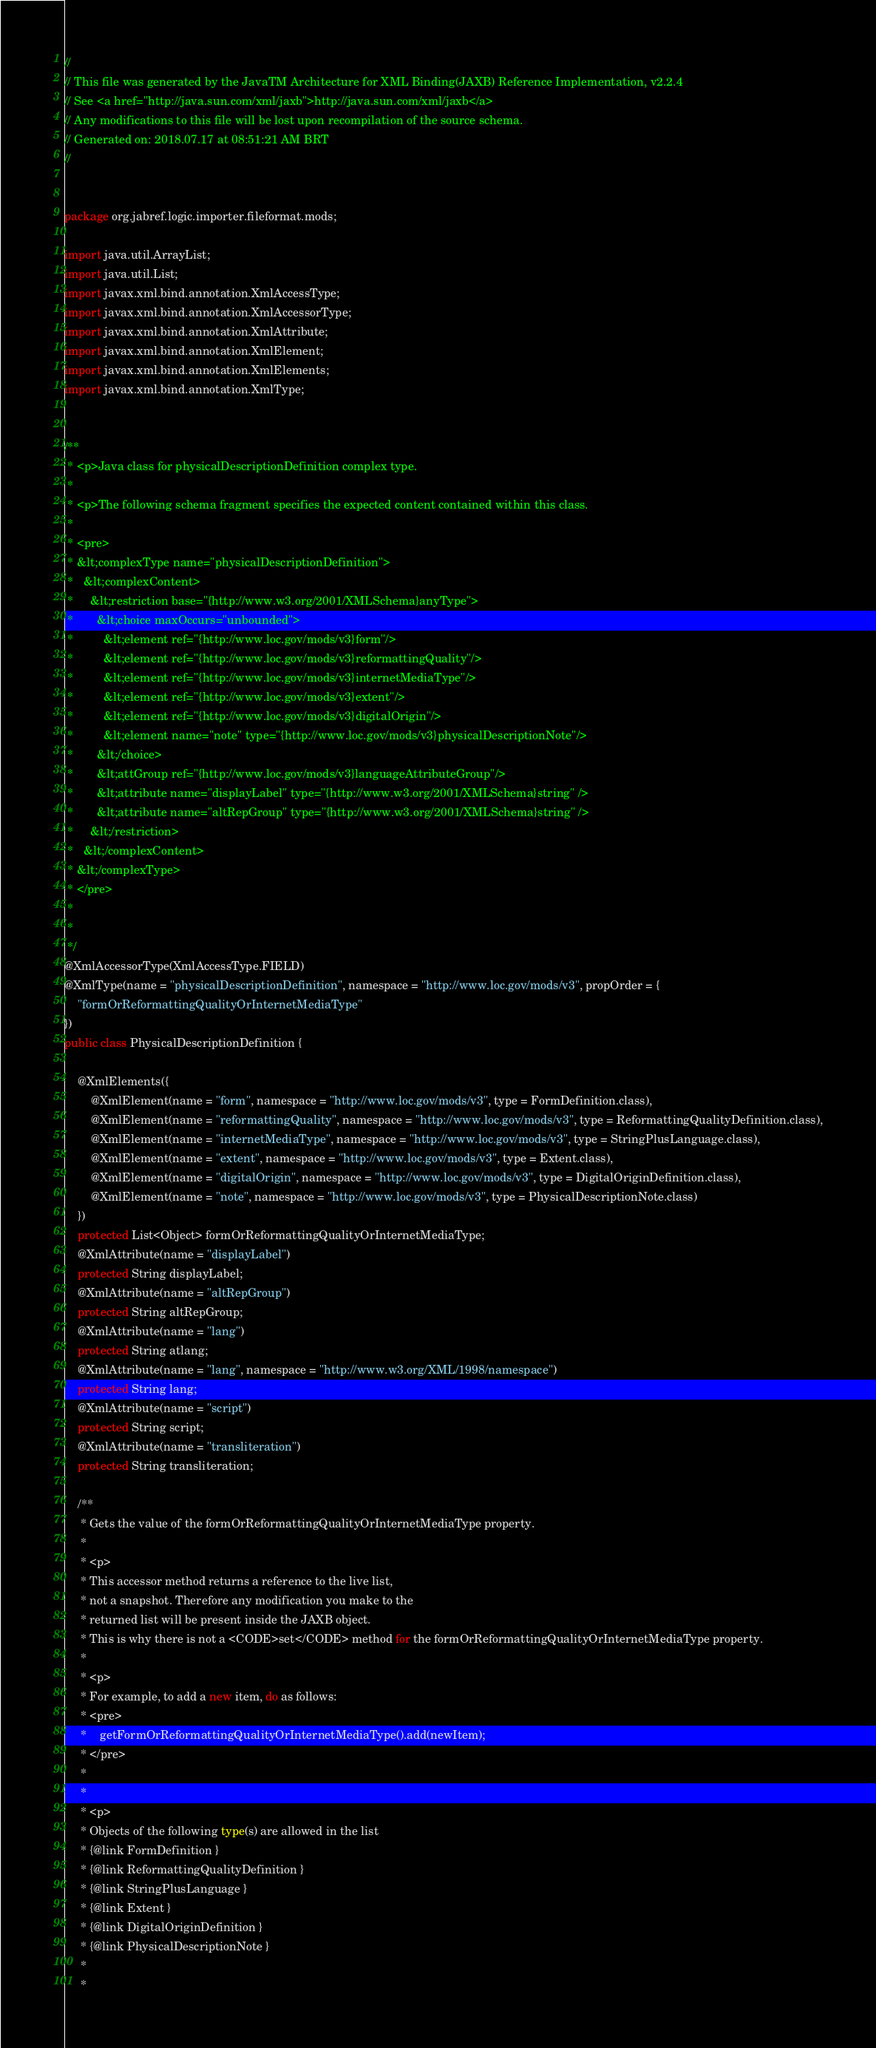Convert code to text. <code><loc_0><loc_0><loc_500><loc_500><_Java_>//
// This file was generated by the JavaTM Architecture for XML Binding(JAXB) Reference Implementation, v2.2.4 
// See <a href="http://java.sun.com/xml/jaxb">http://java.sun.com/xml/jaxb</a> 
// Any modifications to this file will be lost upon recompilation of the source schema. 
// Generated on: 2018.07.17 at 08:51:21 AM BRT 
//


package org.jabref.logic.importer.fileformat.mods;

import java.util.ArrayList;
import java.util.List;
import javax.xml.bind.annotation.XmlAccessType;
import javax.xml.bind.annotation.XmlAccessorType;
import javax.xml.bind.annotation.XmlAttribute;
import javax.xml.bind.annotation.XmlElement;
import javax.xml.bind.annotation.XmlElements;
import javax.xml.bind.annotation.XmlType;


/**
 * <p>Java class for physicalDescriptionDefinition complex type.
 * 
 * <p>The following schema fragment specifies the expected content contained within this class.
 * 
 * <pre>
 * &lt;complexType name="physicalDescriptionDefinition">
 *   &lt;complexContent>
 *     &lt;restriction base="{http://www.w3.org/2001/XMLSchema}anyType">
 *       &lt;choice maxOccurs="unbounded">
 *         &lt;element ref="{http://www.loc.gov/mods/v3}form"/>
 *         &lt;element ref="{http://www.loc.gov/mods/v3}reformattingQuality"/>
 *         &lt;element ref="{http://www.loc.gov/mods/v3}internetMediaType"/>
 *         &lt;element ref="{http://www.loc.gov/mods/v3}extent"/>
 *         &lt;element ref="{http://www.loc.gov/mods/v3}digitalOrigin"/>
 *         &lt;element name="note" type="{http://www.loc.gov/mods/v3}physicalDescriptionNote"/>
 *       &lt;/choice>
 *       &lt;attGroup ref="{http://www.loc.gov/mods/v3}languageAttributeGroup"/>
 *       &lt;attribute name="displayLabel" type="{http://www.w3.org/2001/XMLSchema}string" />
 *       &lt;attribute name="altRepGroup" type="{http://www.w3.org/2001/XMLSchema}string" />
 *     &lt;/restriction>
 *   &lt;/complexContent>
 * &lt;/complexType>
 * </pre>
 * 
 * 
 */
@XmlAccessorType(XmlAccessType.FIELD)
@XmlType(name = "physicalDescriptionDefinition", namespace = "http://www.loc.gov/mods/v3", propOrder = {
    "formOrReformattingQualityOrInternetMediaType"
})
public class PhysicalDescriptionDefinition {

    @XmlElements({
        @XmlElement(name = "form", namespace = "http://www.loc.gov/mods/v3", type = FormDefinition.class),
        @XmlElement(name = "reformattingQuality", namespace = "http://www.loc.gov/mods/v3", type = ReformattingQualityDefinition.class),
        @XmlElement(name = "internetMediaType", namespace = "http://www.loc.gov/mods/v3", type = StringPlusLanguage.class),
        @XmlElement(name = "extent", namespace = "http://www.loc.gov/mods/v3", type = Extent.class),
        @XmlElement(name = "digitalOrigin", namespace = "http://www.loc.gov/mods/v3", type = DigitalOriginDefinition.class),
        @XmlElement(name = "note", namespace = "http://www.loc.gov/mods/v3", type = PhysicalDescriptionNote.class)
    })
    protected List<Object> formOrReformattingQualityOrInternetMediaType;
    @XmlAttribute(name = "displayLabel")
    protected String displayLabel;
    @XmlAttribute(name = "altRepGroup")
    protected String altRepGroup;
    @XmlAttribute(name = "lang")
    protected String atlang;
    @XmlAttribute(name = "lang", namespace = "http://www.w3.org/XML/1998/namespace")
    protected String lang;
    @XmlAttribute(name = "script")
    protected String script;
    @XmlAttribute(name = "transliteration")
    protected String transliteration;

    /**
     * Gets the value of the formOrReformattingQualityOrInternetMediaType property.
     * 
     * <p>
     * This accessor method returns a reference to the live list,
     * not a snapshot. Therefore any modification you make to the
     * returned list will be present inside the JAXB object.
     * This is why there is not a <CODE>set</CODE> method for the formOrReformattingQualityOrInternetMediaType property.
     * 
     * <p>
     * For example, to add a new item, do as follows:
     * <pre>
     *    getFormOrReformattingQualityOrInternetMediaType().add(newItem);
     * </pre>
     * 
     * 
     * <p>
     * Objects of the following type(s) are allowed in the list
     * {@link FormDefinition }
     * {@link ReformattingQualityDefinition }
     * {@link StringPlusLanguage }
     * {@link Extent }
     * {@link DigitalOriginDefinition }
     * {@link PhysicalDescriptionNote }
     * 
     * </code> 